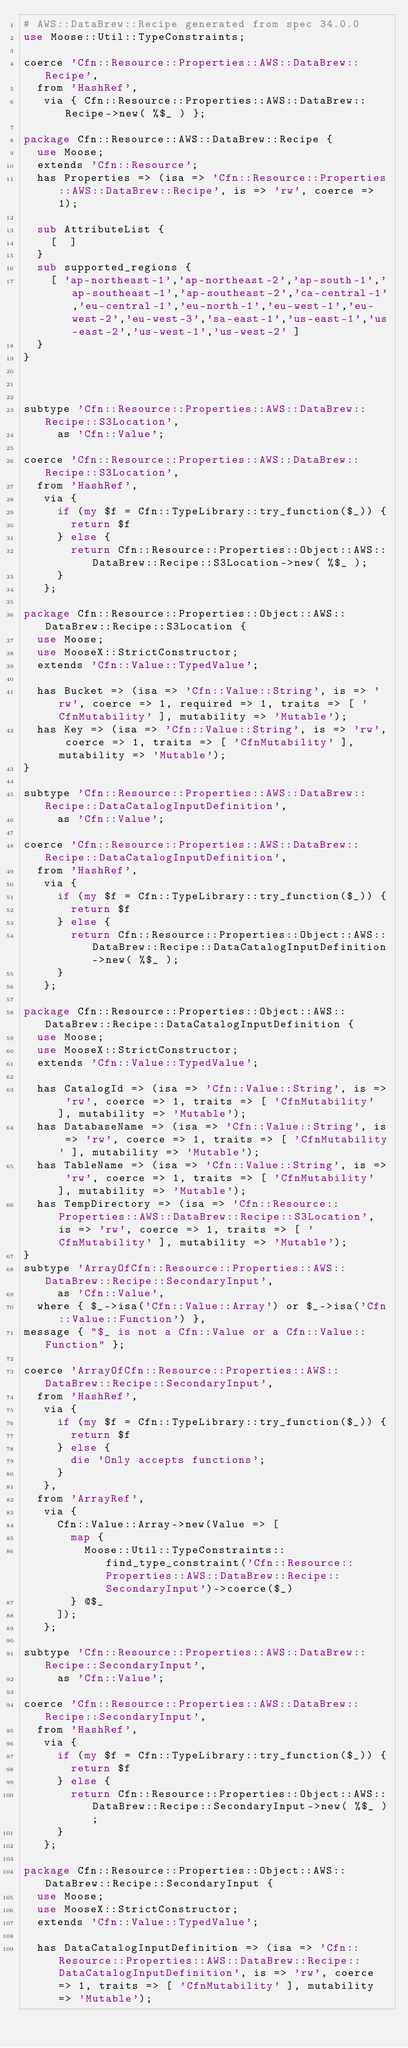<code> <loc_0><loc_0><loc_500><loc_500><_Perl_># AWS::DataBrew::Recipe generated from spec 34.0.0
use Moose::Util::TypeConstraints;

coerce 'Cfn::Resource::Properties::AWS::DataBrew::Recipe',
  from 'HashRef',
   via { Cfn::Resource::Properties::AWS::DataBrew::Recipe->new( %$_ ) };

package Cfn::Resource::AWS::DataBrew::Recipe {
  use Moose;
  extends 'Cfn::Resource';
  has Properties => (isa => 'Cfn::Resource::Properties::AWS::DataBrew::Recipe', is => 'rw', coerce => 1);
  
  sub AttributeList {
    [  ]
  }
  sub supported_regions {
    [ 'ap-northeast-1','ap-northeast-2','ap-south-1','ap-southeast-1','ap-southeast-2','ca-central-1','eu-central-1','eu-north-1','eu-west-1','eu-west-2','eu-west-3','sa-east-1','us-east-1','us-east-2','us-west-1','us-west-2' ]
  }
}



subtype 'Cfn::Resource::Properties::AWS::DataBrew::Recipe::S3Location',
     as 'Cfn::Value';

coerce 'Cfn::Resource::Properties::AWS::DataBrew::Recipe::S3Location',
  from 'HashRef',
   via {
     if (my $f = Cfn::TypeLibrary::try_function($_)) {
       return $f
     } else {
       return Cfn::Resource::Properties::Object::AWS::DataBrew::Recipe::S3Location->new( %$_ );
     }
   };

package Cfn::Resource::Properties::Object::AWS::DataBrew::Recipe::S3Location {
  use Moose;
  use MooseX::StrictConstructor;
  extends 'Cfn::Value::TypedValue';
  
  has Bucket => (isa => 'Cfn::Value::String', is => 'rw', coerce => 1, required => 1, traits => [ 'CfnMutability' ], mutability => 'Mutable');
  has Key => (isa => 'Cfn::Value::String', is => 'rw', coerce => 1, traits => [ 'CfnMutability' ], mutability => 'Mutable');
}

subtype 'Cfn::Resource::Properties::AWS::DataBrew::Recipe::DataCatalogInputDefinition',
     as 'Cfn::Value';

coerce 'Cfn::Resource::Properties::AWS::DataBrew::Recipe::DataCatalogInputDefinition',
  from 'HashRef',
   via {
     if (my $f = Cfn::TypeLibrary::try_function($_)) {
       return $f
     } else {
       return Cfn::Resource::Properties::Object::AWS::DataBrew::Recipe::DataCatalogInputDefinition->new( %$_ );
     }
   };

package Cfn::Resource::Properties::Object::AWS::DataBrew::Recipe::DataCatalogInputDefinition {
  use Moose;
  use MooseX::StrictConstructor;
  extends 'Cfn::Value::TypedValue';
  
  has CatalogId => (isa => 'Cfn::Value::String', is => 'rw', coerce => 1, traits => [ 'CfnMutability' ], mutability => 'Mutable');
  has DatabaseName => (isa => 'Cfn::Value::String', is => 'rw', coerce => 1, traits => [ 'CfnMutability' ], mutability => 'Mutable');
  has TableName => (isa => 'Cfn::Value::String', is => 'rw', coerce => 1, traits => [ 'CfnMutability' ], mutability => 'Mutable');
  has TempDirectory => (isa => 'Cfn::Resource::Properties::AWS::DataBrew::Recipe::S3Location', is => 'rw', coerce => 1, traits => [ 'CfnMutability' ], mutability => 'Mutable');
}
subtype 'ArrayOfCfn::Resource::Properties::AWS::DataBrew::Recipe::SecondaryInput',
     as 'Cfn::Value',
  where { $_->isa('Cfn::Value::Array') or $_->isa('Cfn::Value::Function') },
message { "$_ is not a Cfn::Value or a Cfn::Value::Function" };

coerce 'ArrayOfCfn::Resource::Properties::AWS::DataBrew::Recipe::SecondaryInput',
  from 'HashRef',
   via {
     if (my $f = Cfn::TypeLibrary::try_function($_)) {
       return $f
     } else {
       die 'Only accepts functions'; 
     }
   },
  from 'ArrayRef',
   via {
     Cfn::Value::Array->new(Value => [
       map { 
         Moose::Util::TypeConstraints::find_type_constraint('Cfn::Resource::Properties::AWS::DataBrew::Recipe::SecondaryInput')->coerce($_)
       } @$_
     ]);
   };

subtype 'Cfn::Resource::Properties::AWS::DataBrew::Recipe::SecondaryInput',
     as 'Cfn::Value';

coerce 'Cfn::Resource::Properties::AWS::DataBrew::Recipe::SecondaryInput',
  from 'HashRef',
   via {
     if (my $f = Cfn::TypeLibrary::try_function($_)) {
       return $f
     } else {
       return Cfn::Resource::Properties::Object::AWS::DataBrew::Recipe::SecondaryInput->new( %$_ );
     }
   };

package Cfn::Resource::Properties::Object::AWS::DataBrew::Recipe::SecondaryInput {
  use Moose;
  use MooseX::StrictConstructor;
  extends 'Cfn::Value::TypedValue';
  
  has DataCatalogInputDefinition => (isa => 'Cfn::Resource::Properties::AWS::DataBrew::Recipe::DataCatalogInputDefinition', is => 'rw', coerce => 1, traits => [ 'CfnMutability' ], mutability => 'Mutable');</code> 